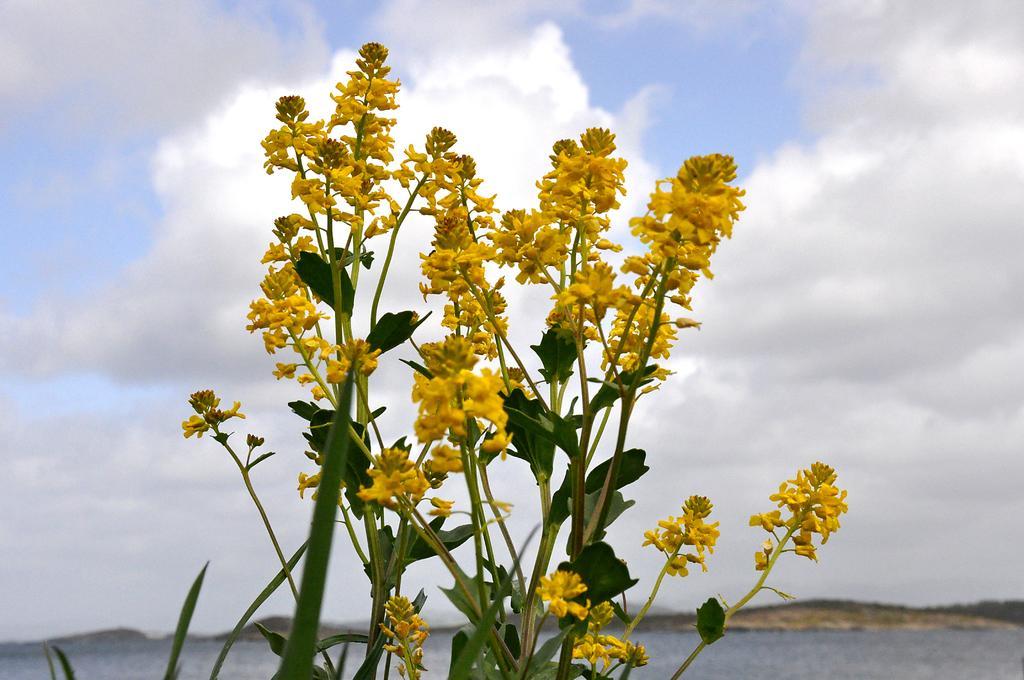Describe this image in one or two sentences. In this image in the front there are flowers and there are leaves. In the background there is water and the sky is cloudy. 